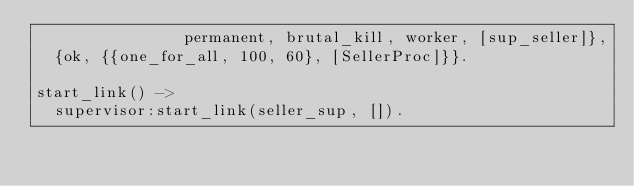<code> <loc_0><loc_0><loc_500><loc_500><_Erlang_>                permanent, brutal_kill, worker, [sup_seller]},
  {ok, {{one_for_all, 100, 60}, [SellerProc]}}.

start_link() ->
  supervisor:start_link(seller_sup, []).
</code> 